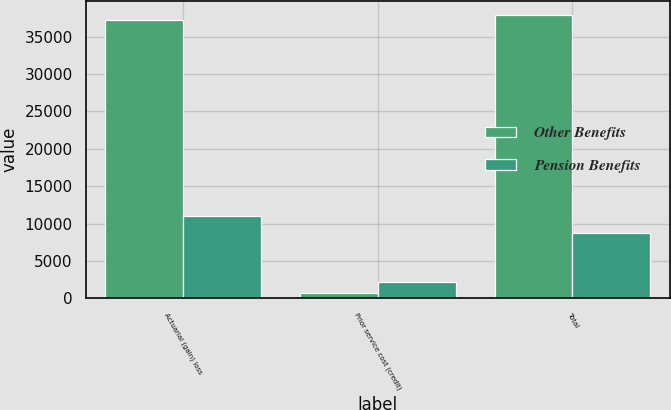Convert chart. <chart><loc_0><loc_0><loc_500><loc_500><stacked_bar_chart><ecel><fcel>Actuarial (gain) loss<fcel>Prior service cost (credit)<fcel>Total<nl><fcel>Other Benefits<fcel>37171<fcel>724<fcel>37895<nl><fcel>Pension Benefits<fcel>10993<fcel>2189<fcel>8804<nl></chart> 